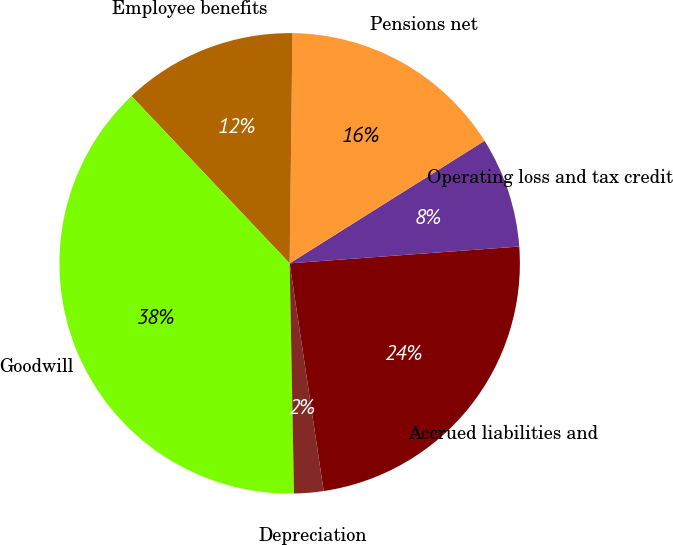Convert chart to OTSL. <chart><loc_0><loc_0><loc_500><loc_500><pie_chart><fcel>Accrued liabilities and<fcel>Operating loss and tax credit<fcel>Pensions net<fcel>Employee benefits<fcel>Goodwill<fcel>Depreciation<nl><fcel>23.8%<fcel>7.77%<fcel>15.87%<fcel>12.25%<fcel>38.24%<fcel>2.06%<nl></chart> 